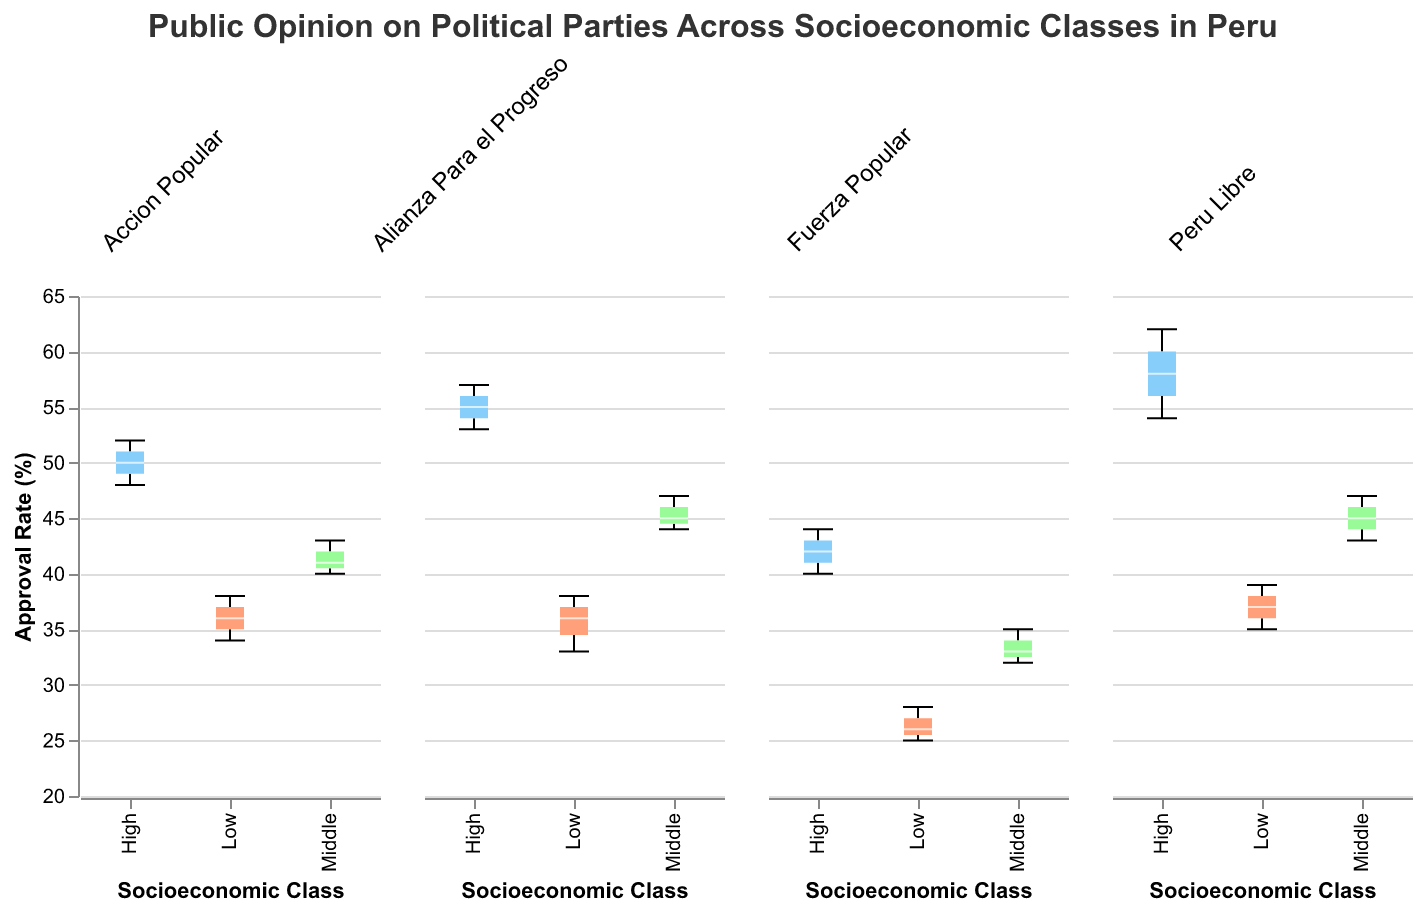Which socioeconomic class has the highest median approval rate for Peru Libre? The median approval rate for Peru Libre in the high socioeconomic class reaches the highest point, indicated by the white line in the box plot for the "High" category.
Answer: High What is the range of approval rates for Fuerza Popular among the middle socioeconomic class? For Fuerza Popular, the middle socioeconomic class shows a range from 32 to 35, evident from the bottom and top whiskers of the box plot for the "Middle" category.
Answer: 32-35 Which political party has the lowest median approval rate among all socioeconomic classes? Comparing the median approval rate across all socioeconomic classes, Fuerza Popular among the low socioeconomic class has the lowest, visible in the lowest white line among all box plots.
Answer: Fuerza Popular How does the median approval rate of Accion Popular in the high socioeconomic class compare to that in the low socioeconomic class? The median approval rate for Accion Popular is higher in the high socioeconomic class than in the low socioeconomic class, as evident by the higher white line in the box plot for the "High" category compared to "Low".
Answer: Higher What is the median approval rate for Alianza Para el Progreso in the middle socioeconomic class? Observing the box plot for Alianza Para el Progreso in the middle socioeconomic class, the median approval rate is at 45, marked by the white line within the box.
Answer: 45 Which socioeconomic class for Alianza Para el Progreso shows the most variability in approval rates? The low socioeconomic class for Alianza Para el Progreso shows the most variability, as seen by the largest range between the bottom and top whiskers in the "Low" category box plot.
Answer: Low Compare the interquartile range (IQR) of the approval rates for Peru Libre and Fuerza Popular among the high socioeconomic class. The interquartile range (IQR) for Peru Libre in the high socioeconomic class is larger than that for Fuerza Popular, visible through a taller box in the Peru Libre plot compared to Fuerza Popular.
Answer: Peru Libre has a larger IQR Which political party has the narrowest range of approval rates across any socioeconomic class? Fuerza Popular in the middle socioeconomic class has the narrowest range of approval rates, shown by the smallest distance between the ends of the whiskers in the box plot for the "Middle" category.
Answer: Fuerza Popular For which socioeconomic class is the approval rate distribution for Accion Popular most symmetrical? The approval rate distribution for Accion Popular is most symmetrical in the middle socioeconomic class, as seen from the approximately equal spread above and below the median (white line) within the box.
Answer: Middle What can be inferred about the relative popularity of Peru Libre among different socioeconomic classes? Peru Libre is relatively more popular among the high socioeconomic class, as indicated by the higher median approval rate compared to the middle and low classes.
Answer: More popular in High 